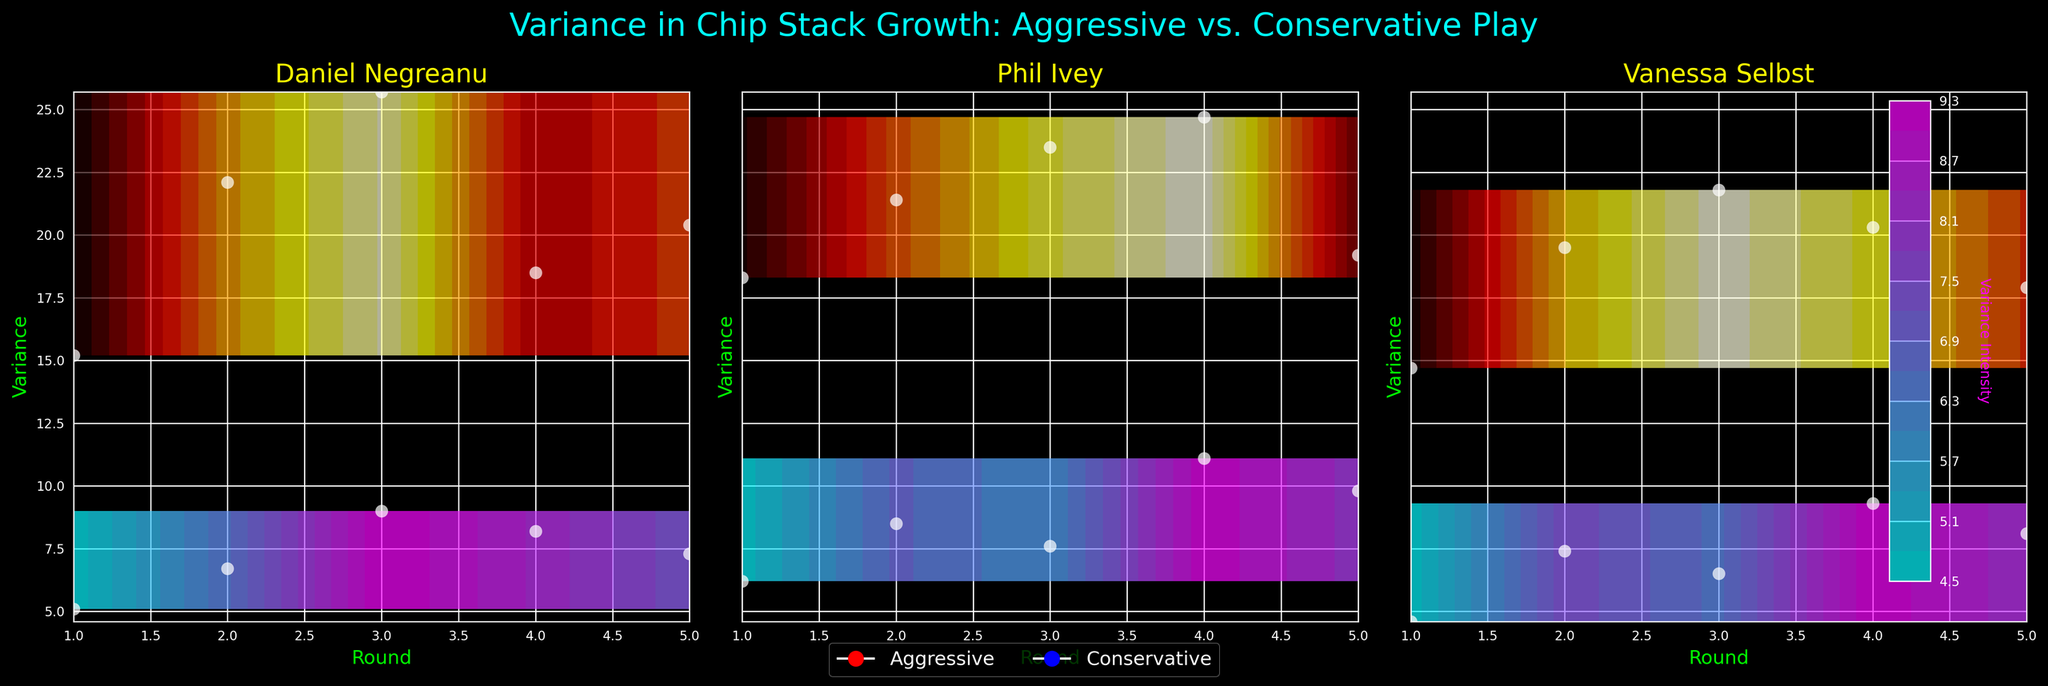What's the title of the figure? The title is located at the top center of the figure and is typically a concise description of the entire graph. For this figure, it is indicated in cyan text.
Answer: Variance in Chip Stack Growth: Aggressive vs. Conservative Play What are the axis labels for each subplot? Each subplot contains axes labeled with the same attributes. The x-axis represents 'Round,' and the y-axis represents 'Variance.' The labels are colored in lime for easier visibility.
Answer: Round (x-axis), Variance (y-axis) Which strategy shows higher variance for Phil Ivey in Round 2? Focus on the subplot for Phil Ivey. Observe the data points for both strategies in Round 2. The variance for the aggressive strategy is visually higher in this round.
Answer: Aggressive How many players are compared in these subplots? Count the number of individual subplots present in the figure. The players' names are indicated in the titles above each subplot.
Answer: 3 Does Vanessa Selbst's aggressive play style show a higher variance than her conservative play style across all rounds? Compare the contour levels and data points for both strategies in Vanessa Selbst's subplot. The colors and height of contour levels indicate that the variance is mostly higher for the aggressive strategy.
Answer: Yes Which player shows the least variance under aggressive play style in Round 1? Look at all subplots and focus on the aggressive strategy’s variance points for Round 1. Identify the player with the lowest data point.
Answer: Vanessa Selbst What is the general trend for variance in aggressive play style as the rounds progress for Daniel Negreanu? Track the series of variance points from Round 1 to Round 5 for Daniel Negreanu's aggressive strategy. There’s a rise from Round 1 to Round 3, then a decrease.
Answer: Rise, then fall Comparing Round 3 for all players, which player demonstrates the highest variance in aggressive strategy? Look at Round 3 in each player's subplot and focus on the data points for the aggressive strategy. Identify the highest point visually.
Answer: Phil Ivey On average, which player has a higher variance in aggressive play tournaments? Calculate the mean variance for the aggressive strategy for all rounds within each player's subplot and compare them.
Answer: Phil Ivey How does the variance in conservative play style for Vanessa Selbst change from Round 2 to Round 4? Follow the trend line within Vanessa Selbst's subplot for the conservative strategy from Round 2 to Round 4. Notice the height of the contour lines and the position of data points. The variance increases from Round 2 to Round 4.
Answer: Increases 